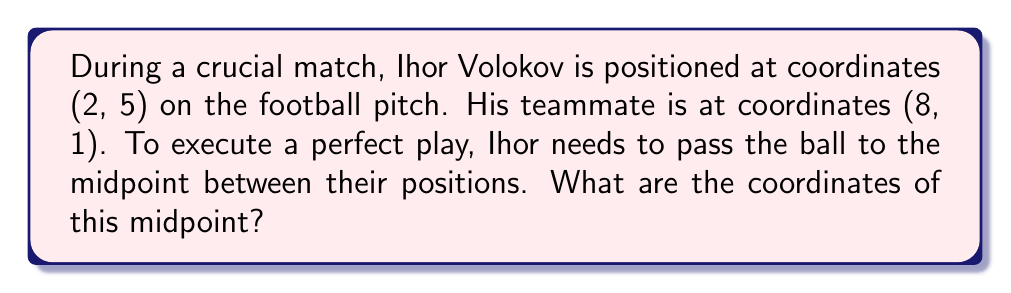Show me your answer to this math problem. To find the midpoint between two points on a coordinate grid, we use the midpoint formula:

$$ \text{Midpoint} = \left(\frac{x_1 + x_2}{2}, \frac{y_1 + y_2}{2}\right) $$

Where $(x_1, y_1)$ are the coordinates of the first point and $(x_2, y_2)$ are the coordinates of the second point.

In this case:
- Ihor Volokov's position: $(x_1, y_1) = (2, 5)$
- Teammate's position: $(x_2, y_2) = (8, 1)$

Let's calculate the x-coordinate of the midpoint:
$$ x = \frac{x_1 + x_2}{2} = \frac{2 + 8}{2} = \frac{10}{2} = 5 $$

Now, let's calculate the y-coordinate of the midpoint:
$$ y = \frac{y_1 + y_2}{2} = \frac{5 + 1}{2} = \frac{6}{2} = 3 $$

Therefore, the midpoint coordinates are $(5, 3)$.
Answer: The coordinates of the midpoint are $(5, 3)$. 